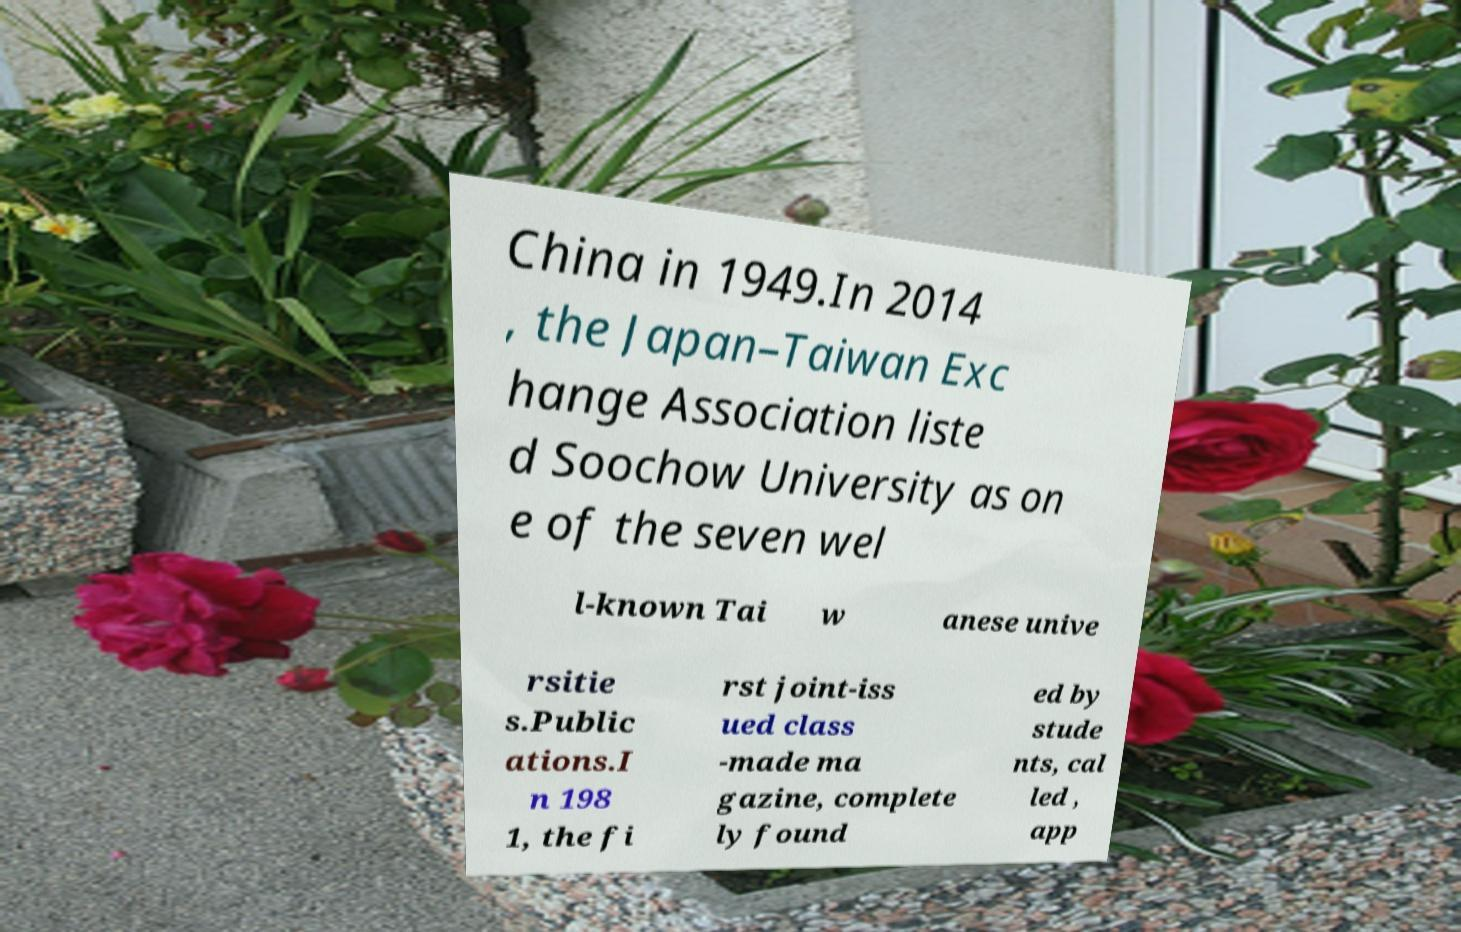Could you assist in decoding the text presented in this image and type it out clearly? China in 1949.In 2014 , the Japan–Taiwan Exc hange Association liste d Soochow University as on e of the seven wel l-known Tai w anese unive rsitie s.Public ations.I n 198 1, the fi rst joint-iss ued class -made ma gazine, complete ly found ed by stude nts, cal led , app 